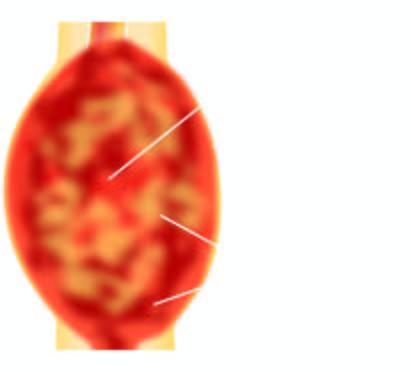s formation of granulation tissue largely extending into soft tissues including the skeletal muscle?
Answer the question using a single word or phrase. No 